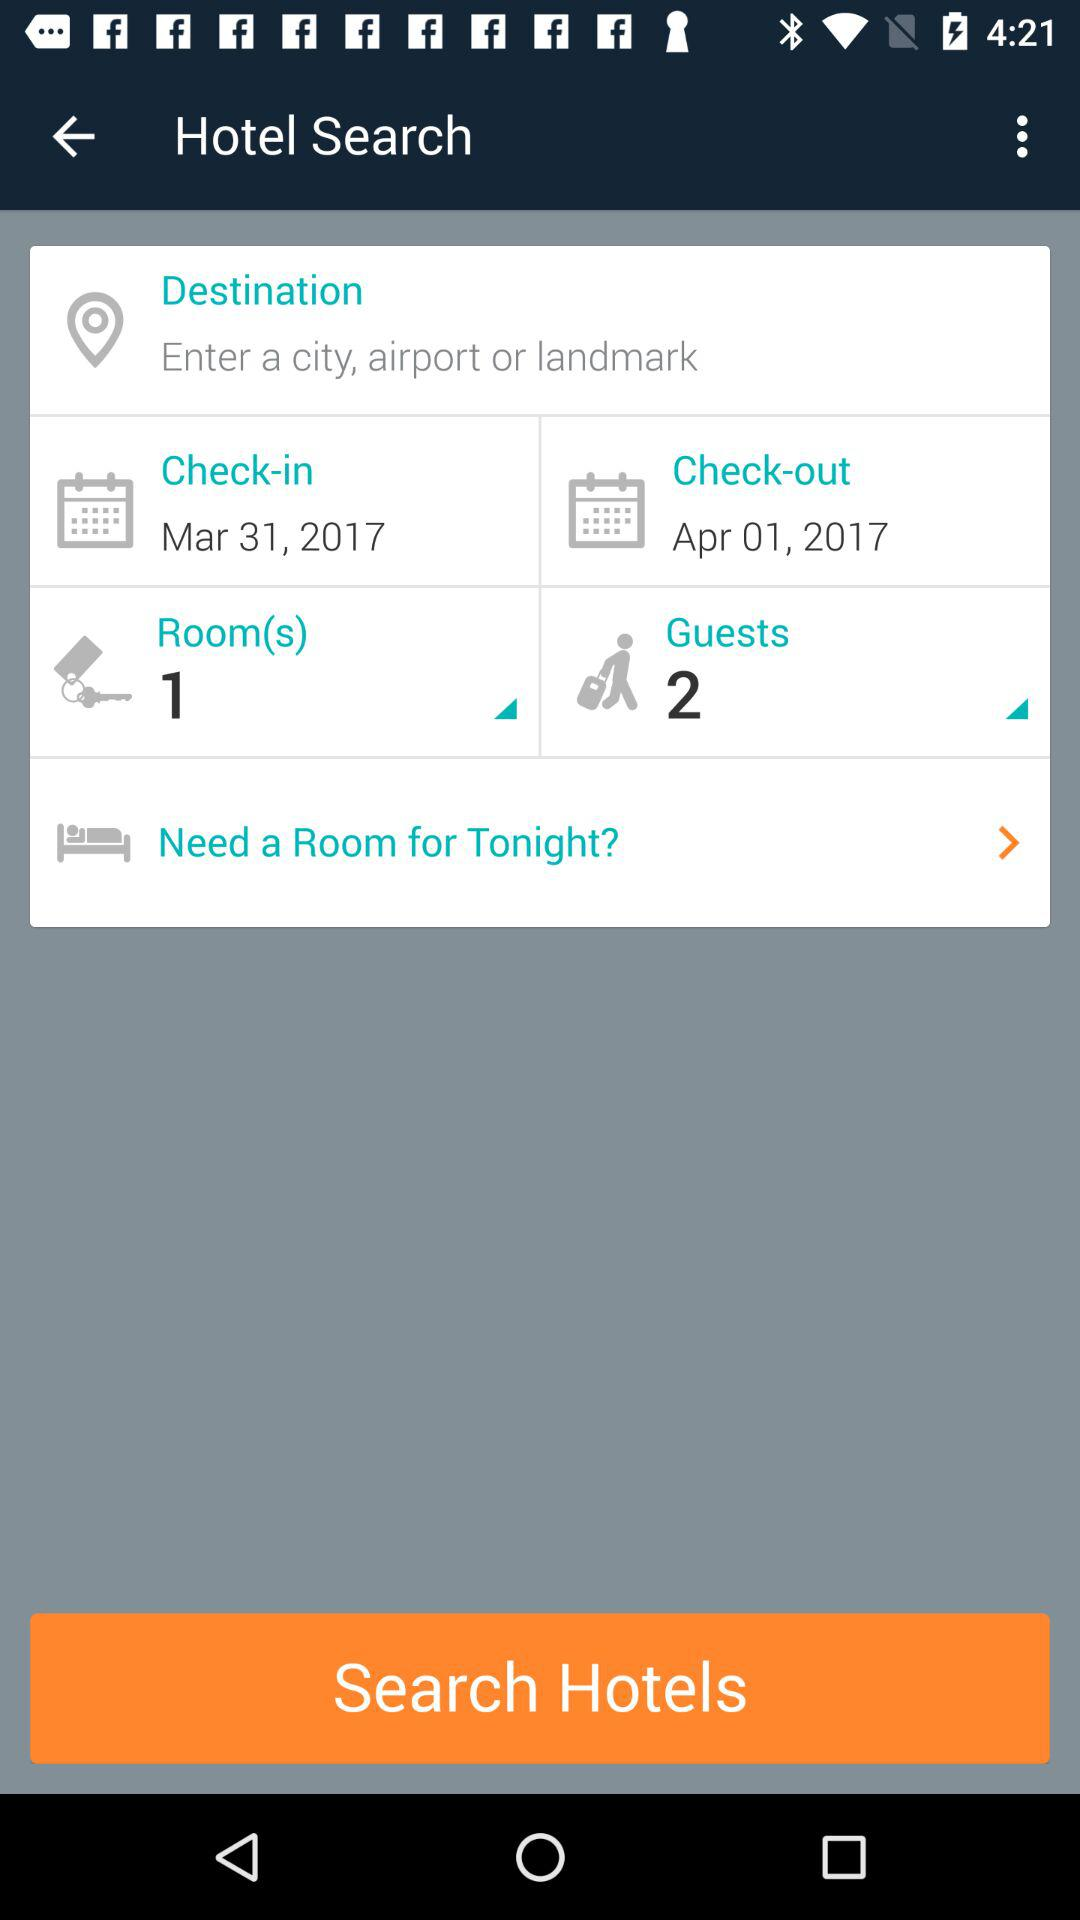How many guests are there? There are two guests. 